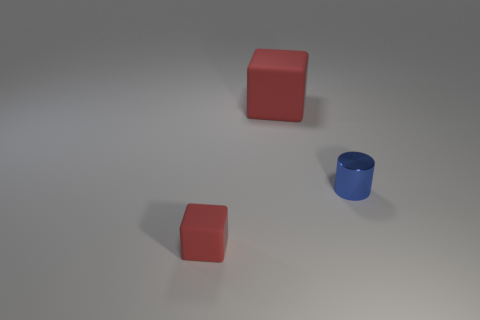How many red cubes must be subtracted to get 1 red cubes? 1 Add 1 blue objects. How many objects exist? 4 Subtract all blocks. How many objects are left? 1 Add 3 blocks. How many blocks exist? 5 Subtract 0 yellow blocks. How many objects are left? 3 Subtract all small brown things. Subtract all cubes. How many objects are left? 1 Add 2 big matte objects. How many big matte objects are left? 3 